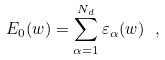<formula> <loc_0><loc_0><loc_500><loc_500>E _ { 0 } ( w ) = \sum _ { \alpha = 1 } ^ { N _ { d } } \varepsilon _ { \alpha } ( w ) \ ,</formula> 